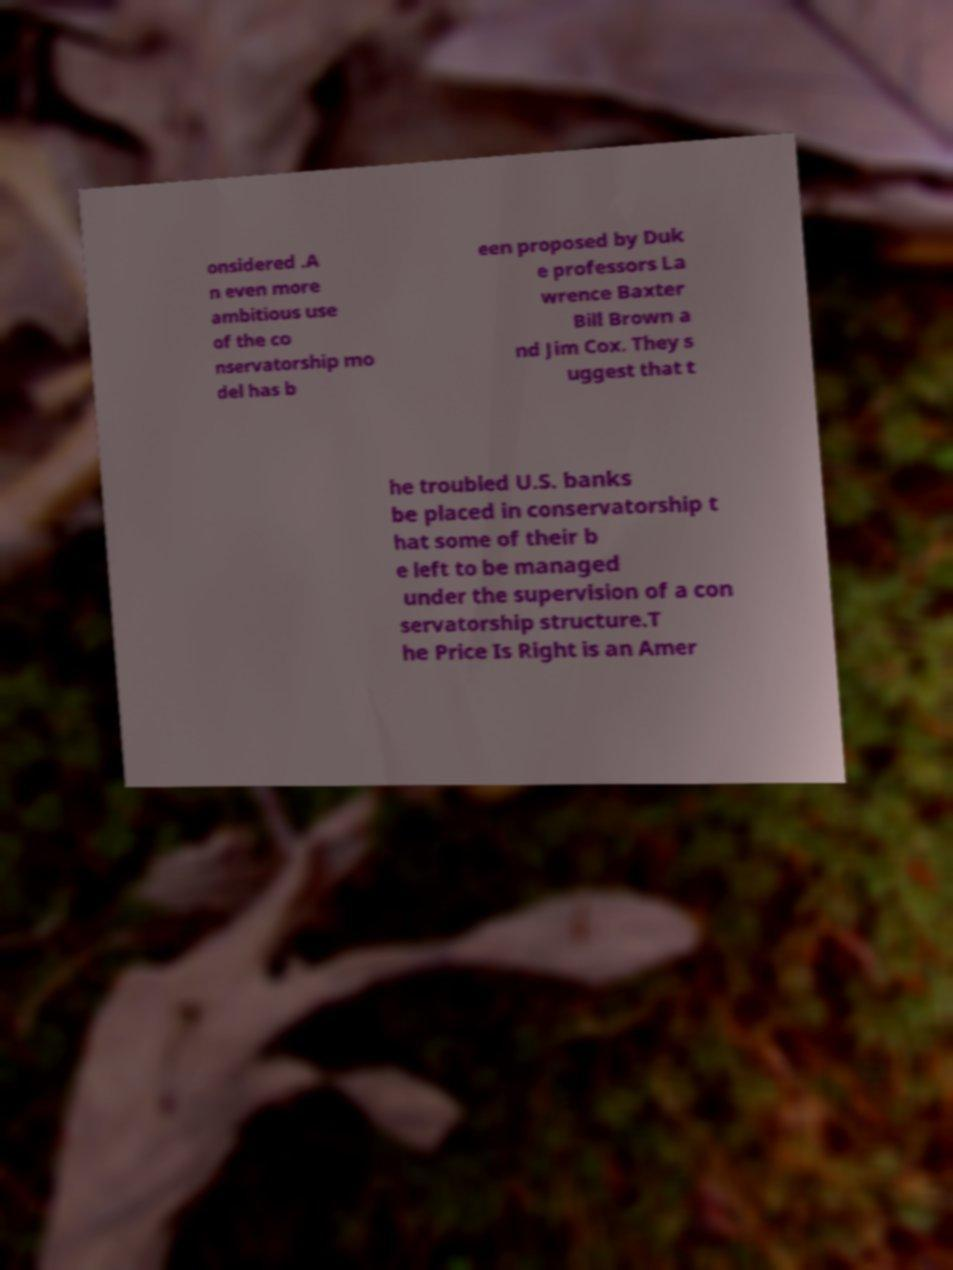Could you assist in decoding the text presented in this image and type it out clearly? onsidered .A n even more ambitious use of the co nservatorship mo del has b een proposed by Duk e professors La wrence Baxter Bill Brown a nd Jim Cox. They s uggest that t he troubled U.S. banks be placed in conservatorship t hat some of their b e left to be managed under the supervision of a con servatorship structure.T he Price Is Right is an Amer 